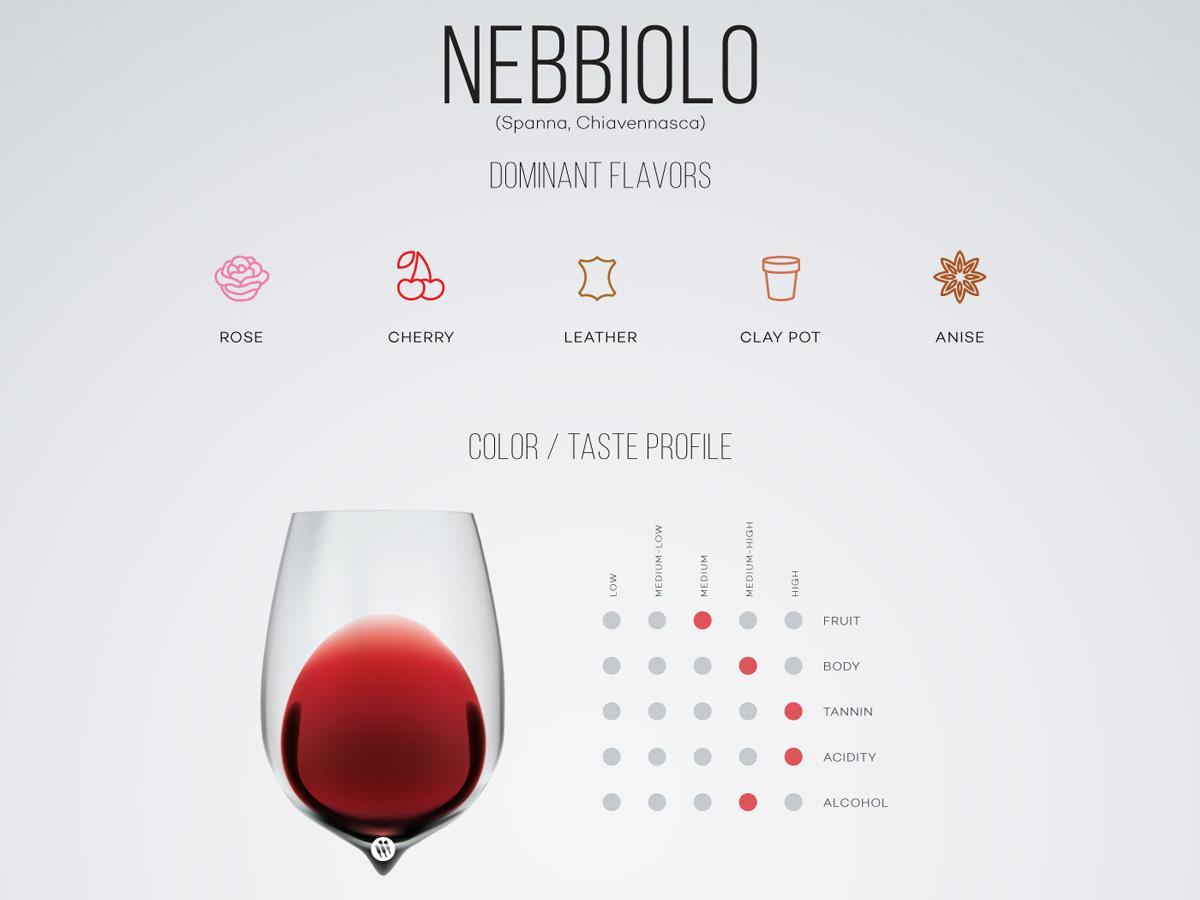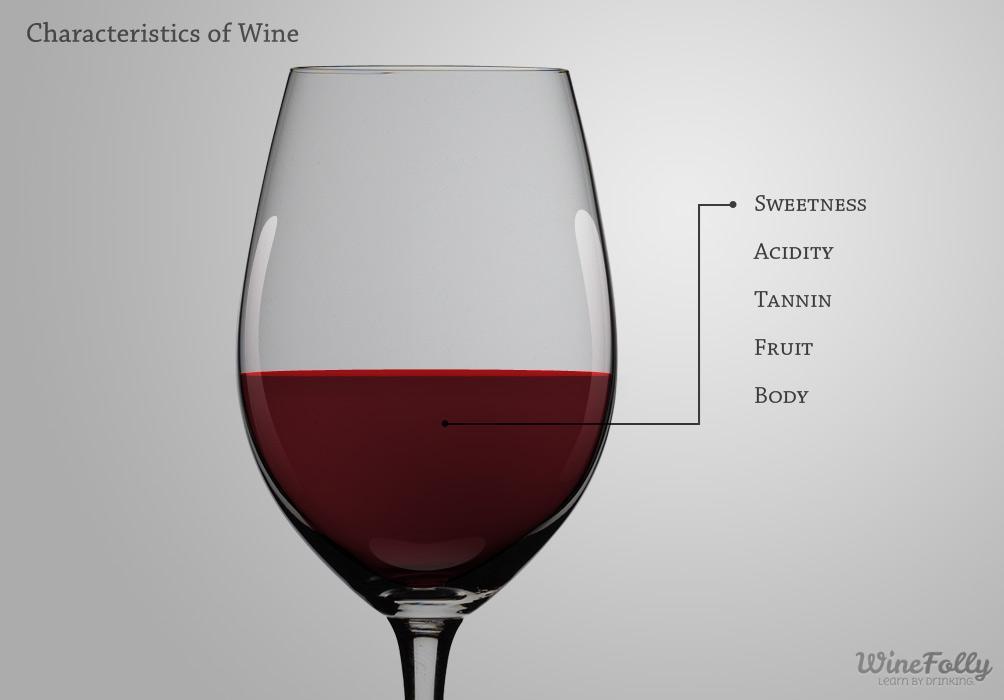The first image is the image on the left, the second image is the image on the right. Examine the images to the left and right. Is the description "An image shows wine glass with wine inside level and flat on top." accurate? Answer yes or no. Yes. 